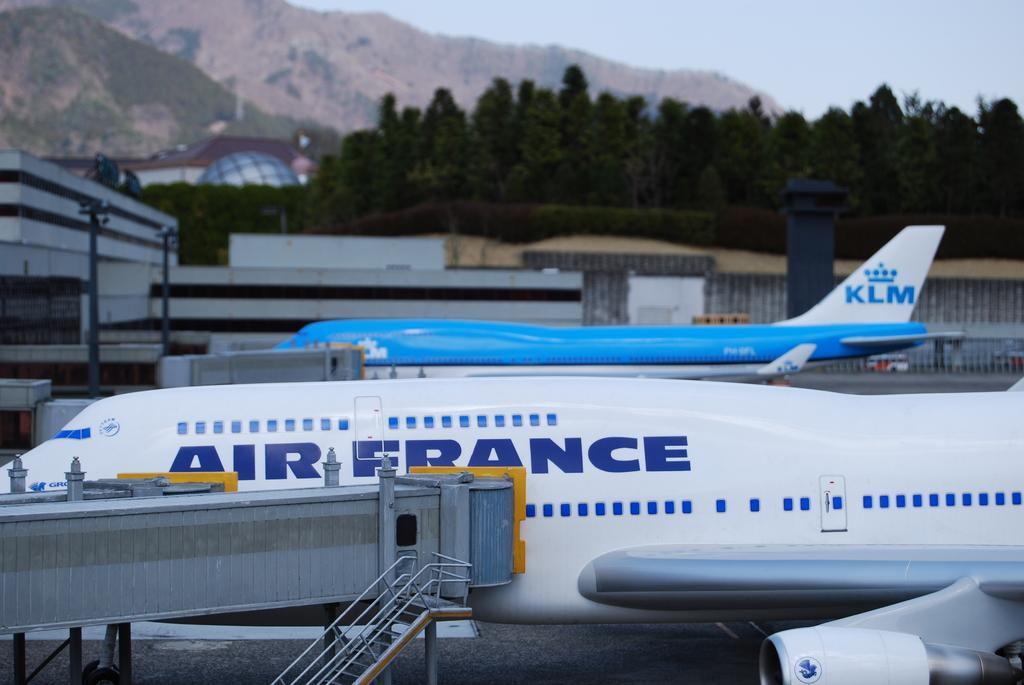<image>
Offer a succinct explanation of the picture presented. white air france airplane and blue and white plane with klm on the tail 